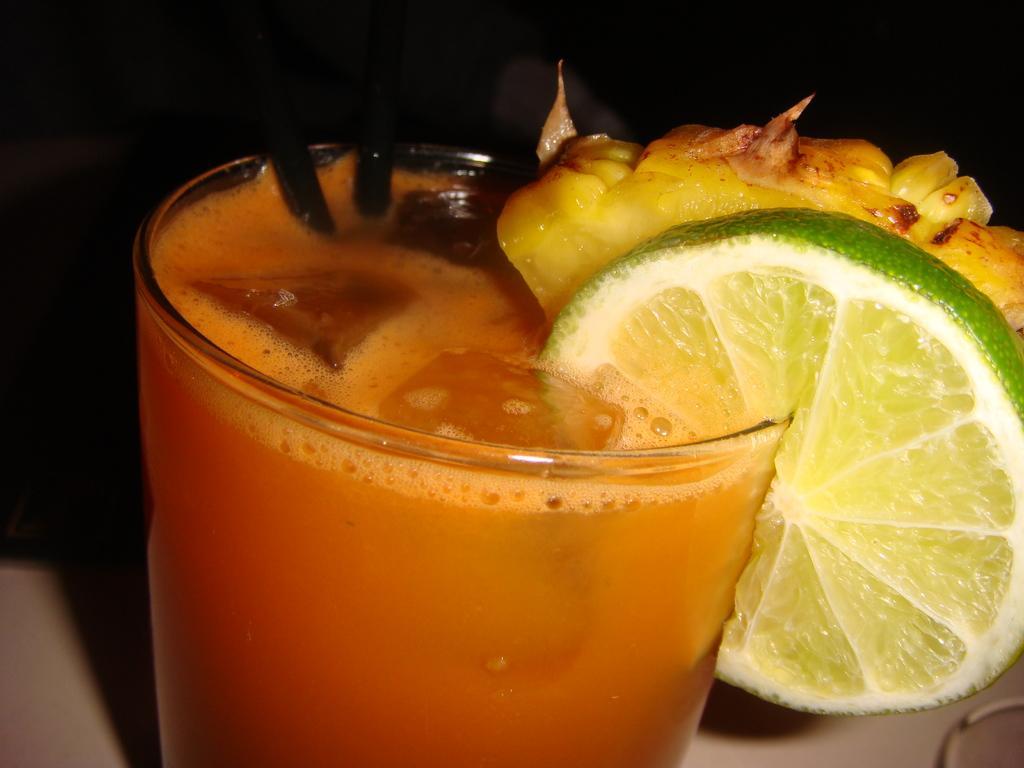Could you give a brief overview of what you see in this image? In this image, we can see a glass with some liquid, a lemon slice and an object. We can also see the ground and the dark background. We can also see an object on the bottom right corner. 